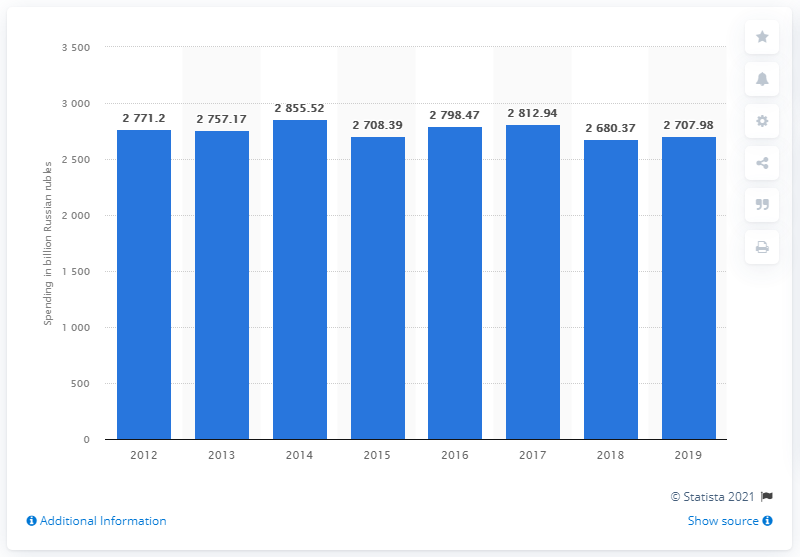List a handful of essential elements in this visual. In 2019, the value of domestic travel and tourism spending in Russia was 2707.98 million dollars. 